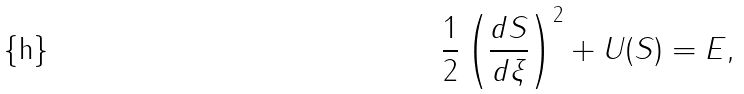<formula> <loc_0><loc_0><loc_500><loc_500>\frac { 1 } { 2 } \left ( \frac { d S } { d \xi } \right ) ^ { 2 } + U ( S ) = E ,</formula> 